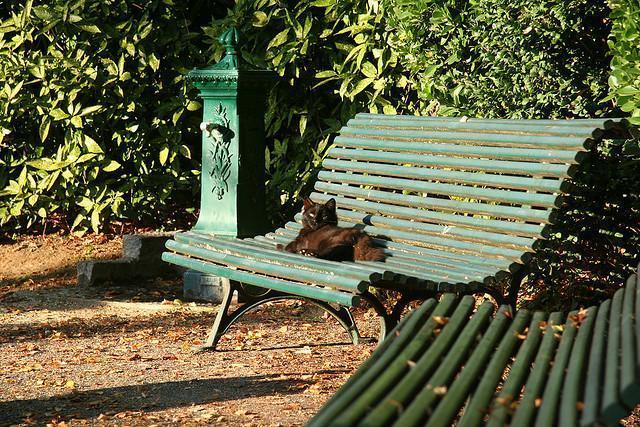How many benches are there?
Give a very brief answer. 2. How many boats are moving in the photo?
Give a very brief answer. 0. 